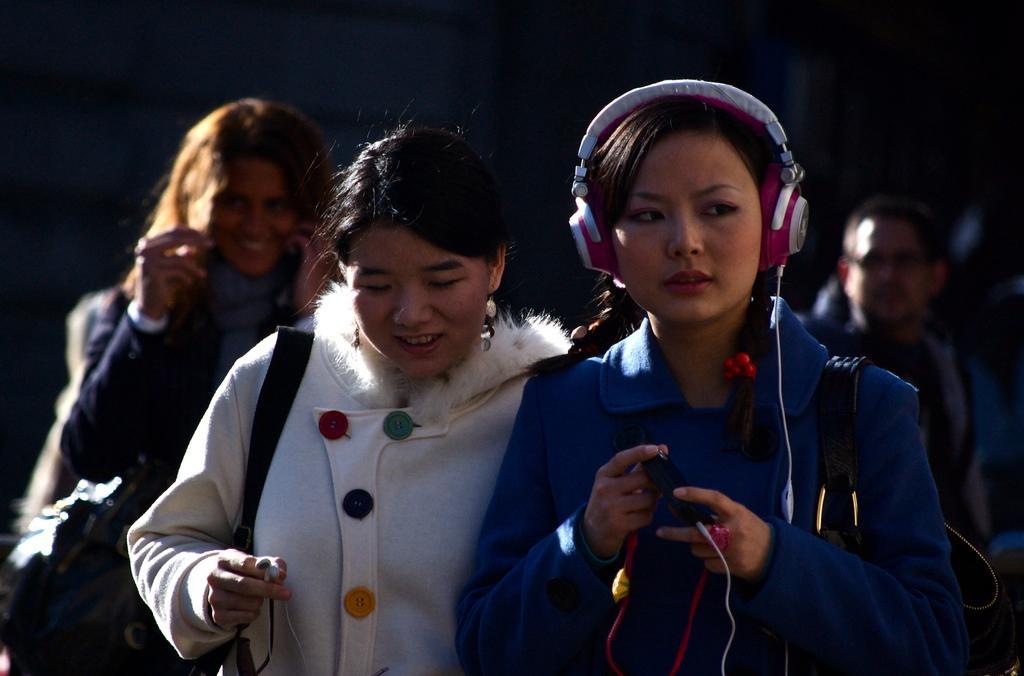Please provide a concise description of this image. In the image in the center we can see three persons were standing and holding some objects. And they were smiling,which we can see on their faces. And the right side woman is wearing headphones. In the background there is a person standing. 